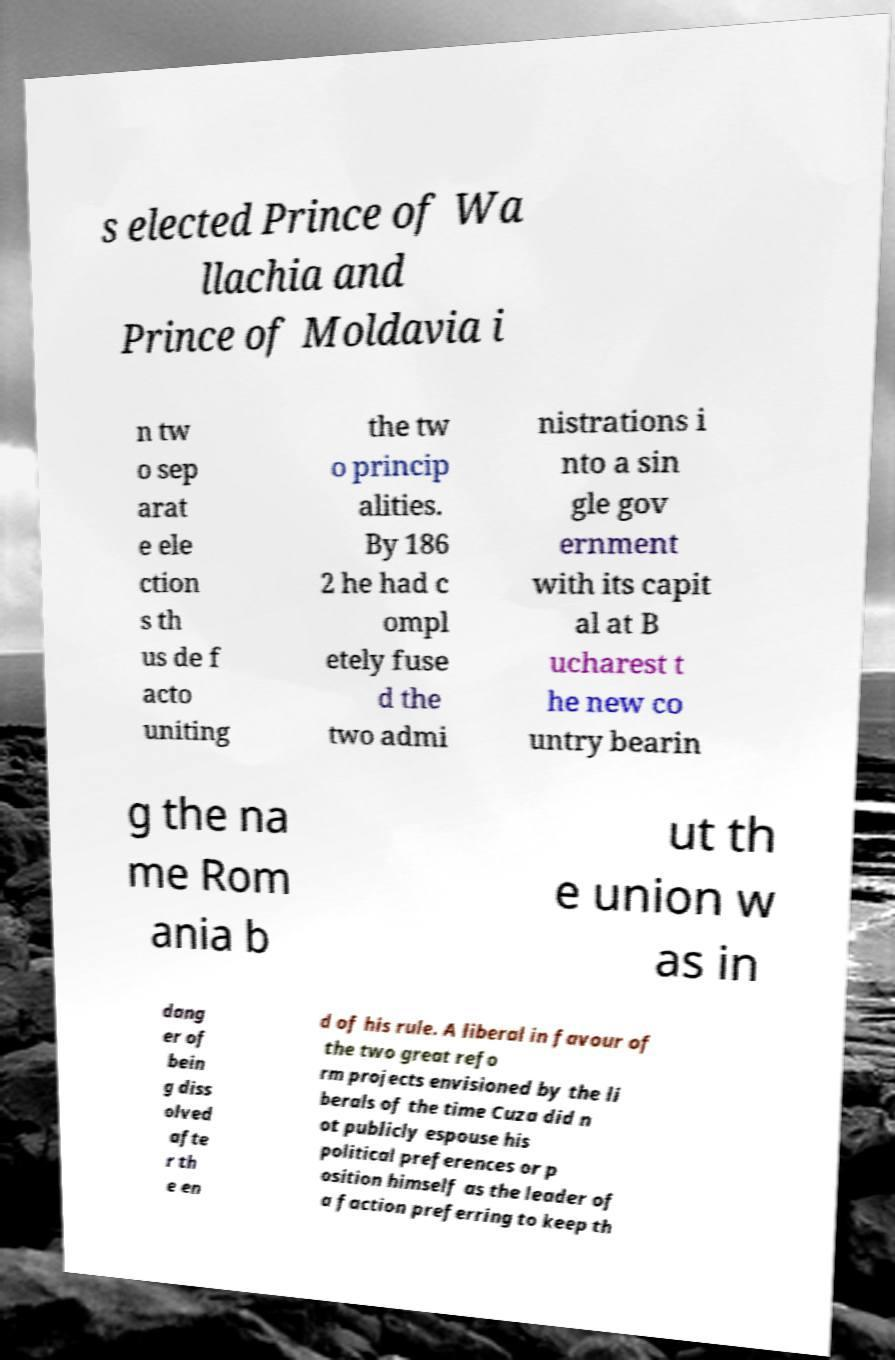What messages or text are displayed in this image? I need them in a readable, typed format. s elected Prince of Wa llachia and Prince of Moldavia i n tw o sep arat e ele ction s th us de f acto uniting the tw o princip alities. By 186 2 he had c ompl etely fuse d the two admi nistrations i nto a sin gle gov ernment with its capit al at B ucharest t he new co untry bearin g the na me Rom ania b ut th e union w as in dang er of bein g diss olved afte r th e en d of his rule. A liberal in favour of the two great refo rm projects envisioned by the li berals of the time Cuza did n ot publicly espouse his political preferences or p osition himself as the leader of a faction preferring to keep th 